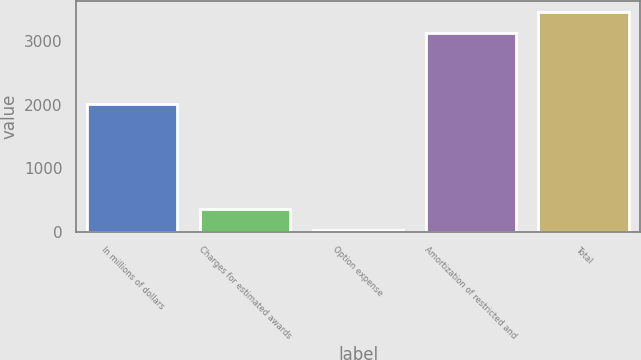<chart> <loc_0><loc_0><loc_500><loc_500><bar_chart><fcel>In millions of dollars<fcel>Charges for estimated awards<fcel>Option expense<fcel>Amortization of restricted and<fcel>Total<nl><fcel>2008<fcel>355.1<fcel>29<fcel>3133<fcel>3459.1<nl></chart> 